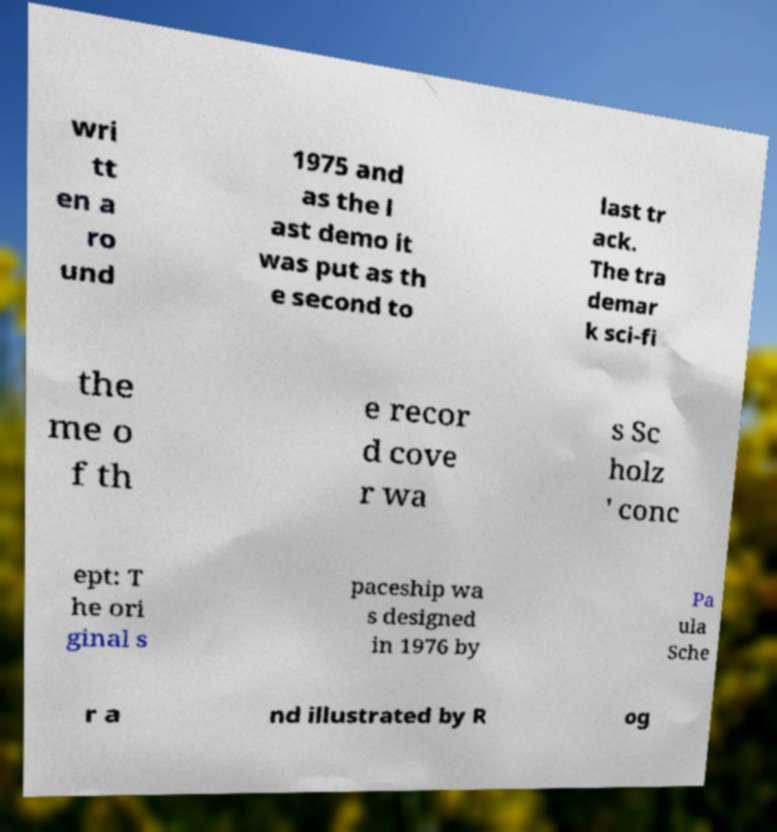For documentation purposes, I need the text within this image transcribed. Could you provide that? wri tt en a ro und 1975 and as the l ast demo it was put as th e second to last tr ack. The tra demar k sci-fi the me o f th e recor d cove r wa s Sc holz ' conc ept: T he ori ginal s paceship wa s designed in 1976 by Pa ula Sche r a nd illustrated by R og 